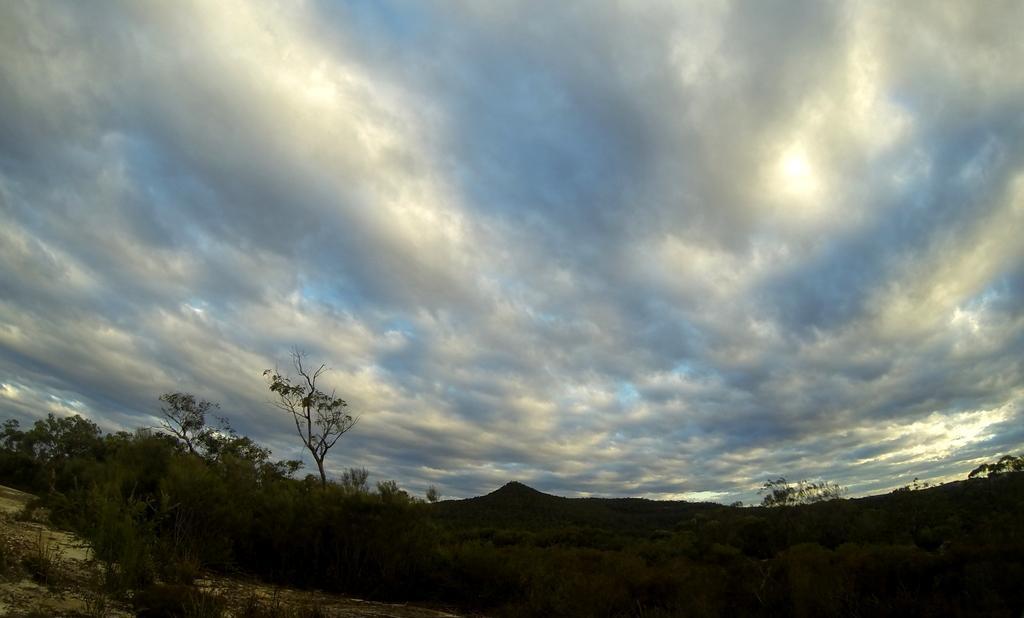Please provide a concise description of this image. In this image there are many trees. At the top of the image there are many clouds. 